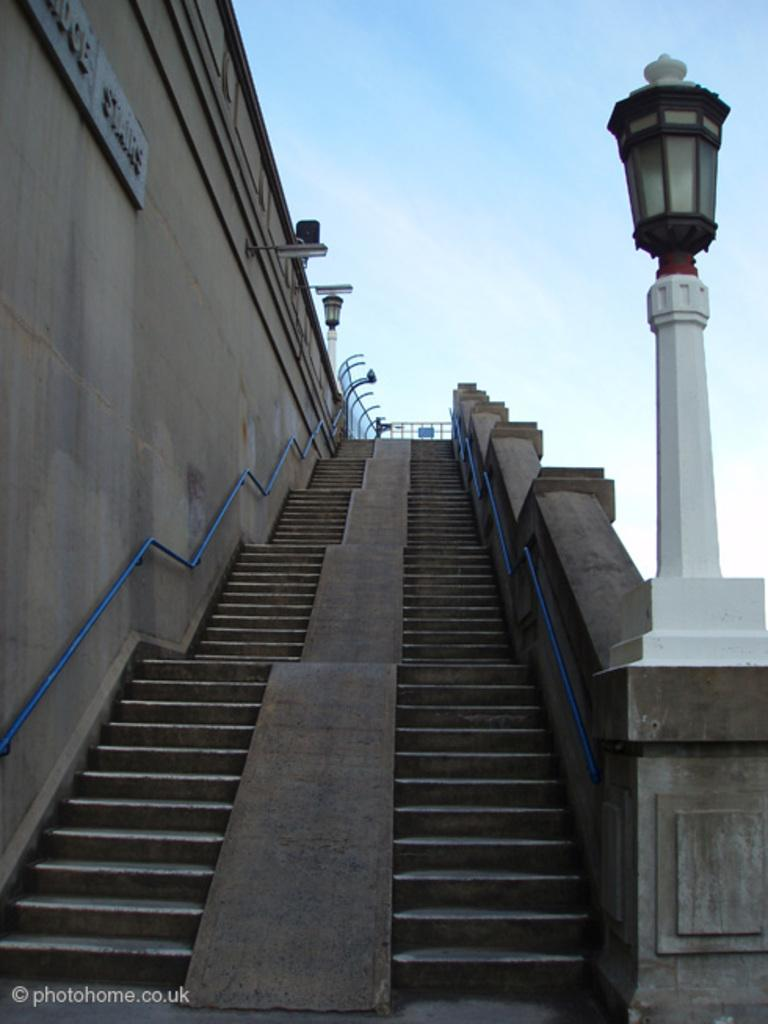What celestial objects can be seen in the image? There are stars in the image. What else can be seen in the image besides stars? There are lights and a board on the wall visible in the image. What is visible in the background of the image? The sky is visible in the background of the image. Can you describe any additional features of the image? There is a watermark on the image. What type of trousers are hanging on the board in the image? There are no trousers present in the image; the board on the wall is empty. Can you tell me how much bait is being used in the image? There is no reference to bait or any fishing activity in the image. 